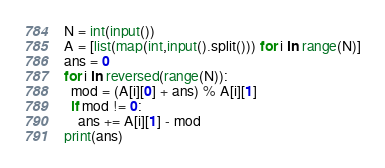Convert code to text. <code><loc_0><loc_0><loc_500><loc_500><_Python_>N = int(input())
A = [list(map(int,input().split())) for i in range(N)]
ans = 0
for i in reversed(range(N)):
  mod = (A[i][0] + ans) % A[i][1]
  if mod != 0:
    ans += A[i][1] - mod
print(ans)</code> 